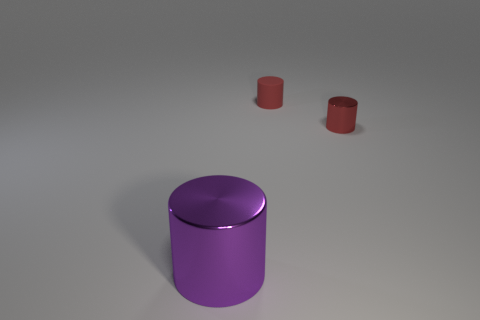Add 1 tiny brown shiny spheres. How many objects exist? 4 Subtract all red cylinders. How many cylinders are left? 1 Subtract all small cylinders. How many cylinders are left? 1 Subtract 0 purple blocks. How many objects are left? 3 Subtract all yellow cylinders. Subtract all cyan cubes. How many cylinders are left? 3 Subtract all purple cubes. How many purple cylinders are left? 1 Subtract all big brown metal cylinders. Subtract all big cylinders. How many objects are left? 2 Add 1 purple things. How many purple things are left? 2 Add 3 tiny red cylinders. How many tiny red cylinders exist? 5 